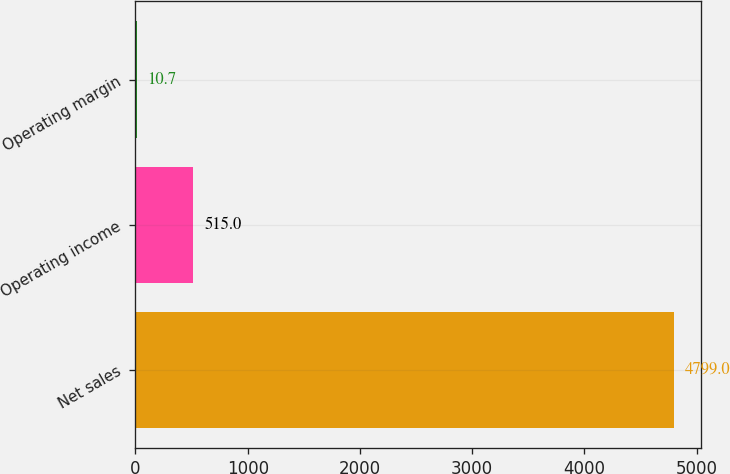Convert chart. <chart><loc_0><loc_0><loc_500><loc_500><bar_chart><fcel>Net sales<fcel>Operating income<fcel>Operating margin<nl><fcel>4799<fcel>515<fcel>10.7<nl></chart> 